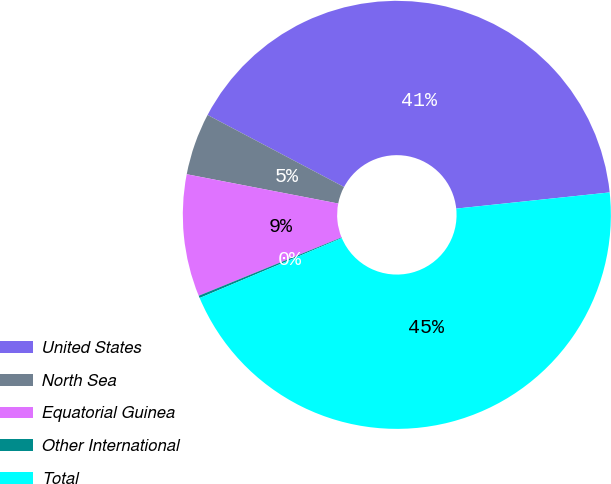Convert chart. <chart><loc_0><loc_0><loc_500><loc_500><pie_chart><fcel>United States<fcel>North Sea<fcel>Equatorial Guinea<fcel>Other International<fcel>Total<nl><fcel>40.6%<fcel>4.69%<fcel>9.21%<fcel>0.18%<fcel>45.32%<nl></chart> 